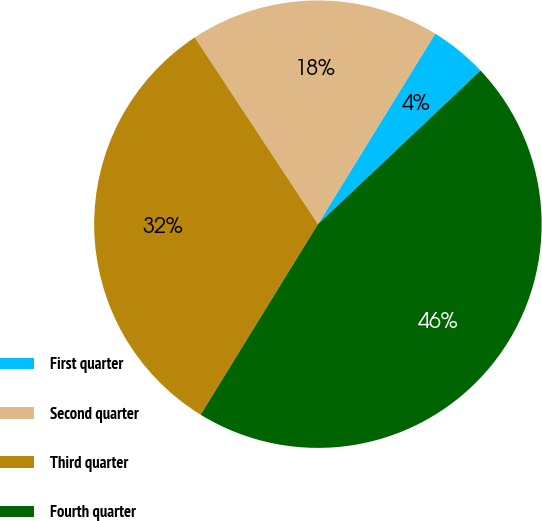Convert chart. <chart><loc_0><loc_0><loc_500><loc_500><pie_chart><fcel>First quarter<fcel>Second quarter<fcel>Third quarter<fcel>Fourth quarter<nl><fcel>4.17%<fcel>18.06%<fcel>31.94%<fcel>45.83%<nl></chart> 